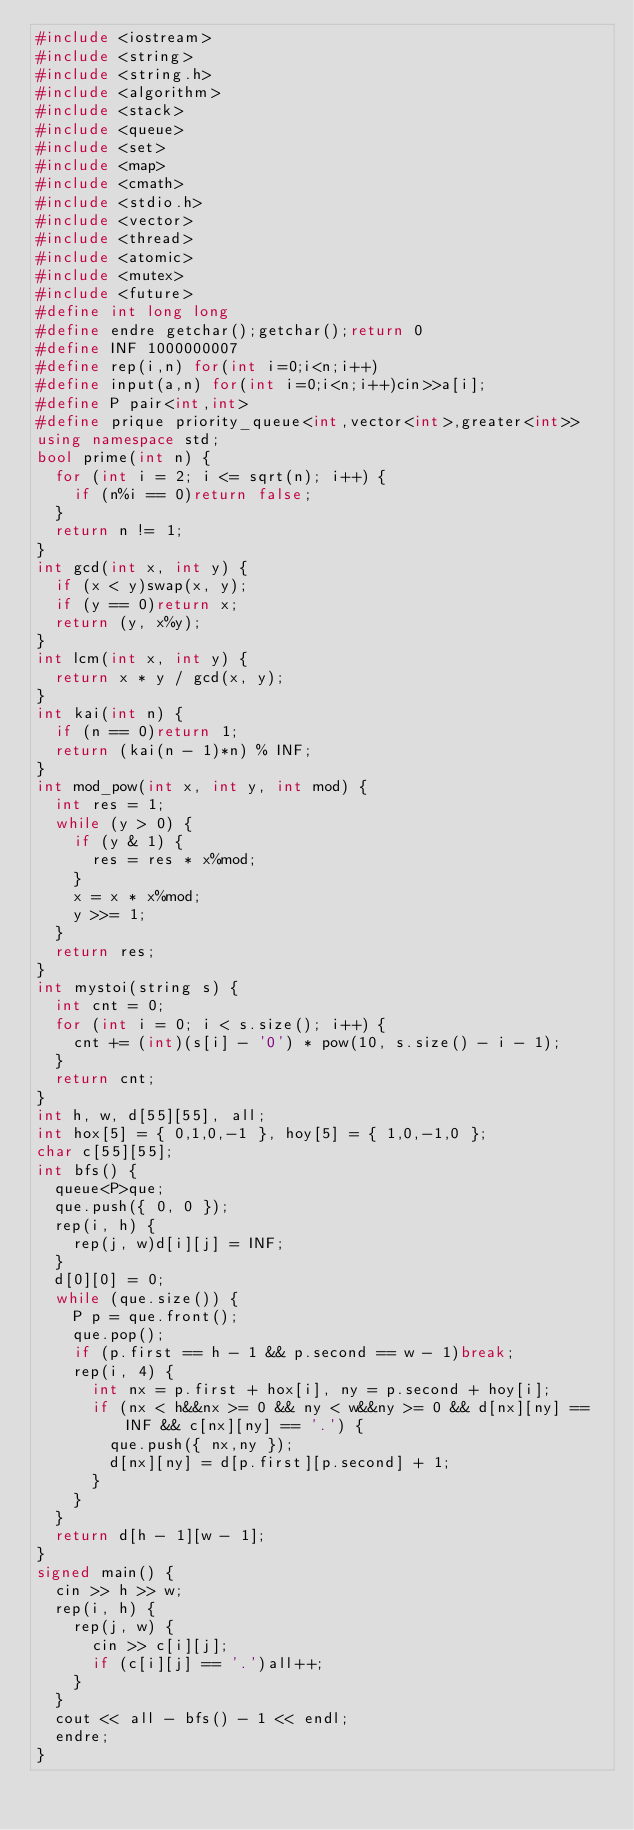Convert code to text. <code><loc_0><loc_0><loc_500><loc_500><_C++_>#include <iostream>
#include <string>
#include <string.h>
#include <algorithm>
#include <stack>
#include <queue>
#include <set>
#include <map>
#include <cmath>
#include <stdio.h>
#include <vector>
#include <thread>
#include <atomic>
#include <mutex>
#include <future>
#define int long long
#define endre getchar();getchar();return 0
#define INF 1000000007
#define rep(i,n) for(int i=0;i<n;i++)
#define input(a,n) for(int i=0;i<n;i++)cin>>a[i];
#define P pair<int,int>
#define prique priority_queue<int,vector<int>,greater<int>>
using namespace std;
bool prime(int n) {
	for (int i = 2; i <= sqrt(n); i++) {
		if (n%i == 0)return false;
	}
	return n != 1;
}
int gcd(int x, int y) {
	if (x < y)swap(x, y);
	if (y == 0)return x;
	return (y, x%y);
}
int lcm(int x, int y) {
	return x * y / gcd(x, y);
}
int kai(int n) {
	if (n == 0)return 1;
	return (kai(n - 1)*n) % INF;
}
int mod_pow(int x, int y, int mod) {
	int res = 1;
	while (y > 0) {
		if (y & 1) {
			res = res * x%mod;
		}
		x = x * x%mod;
		y >>= 1;
	}
	return res;
}
int mystoi(string s) {
	int cnt = 0;
	for (int i = 0; i < s.size(); i++) {
		cnt += (int)(s[i] - '0') * pow(10, s.size() - i - 1);
	}
	return cnt;
}
int h, w, d[55][55], all;
int hox[5] = { 0,1,0,-1 }, hoy[5] = { 1,0,-1,0 };
char c[55][55];
int bfs() {
	queue<P>que;
	que.push({ 0, 0 });
	rep(i, h) {
		rep(j, w)d[i][j] = INF;
	}
	d[0][0] = 0;
	while (que.size()) {
		P p = que.front();
		que.pop();
		if (p.first == h - 1 && p.second == w - 1)break;
		rep(i, 4) {
			int nx = p.first + hox[i], ny = p.second + hoy[i];
			if (nx < h&&nx >= 0 && ny < w&&ny >= 0 && d[nx][ny] == INF && c[nx][ny] == '.') {
				que.push({ nx,ny });
				d[nx][ny] = d[p.first][p.second] + 1;
			}
		}
	}
	return d[h - 1][w - 1];
}
signed main() {
	cin >> h >> w;
	rep(i, h) {
		rep(j, w) {
			cin >> c[i][j];
			if (c[i][j] == '.')all++;
		}
	}
	cout << all - bfs() - 1 << endl;
	endre;
}</code> 